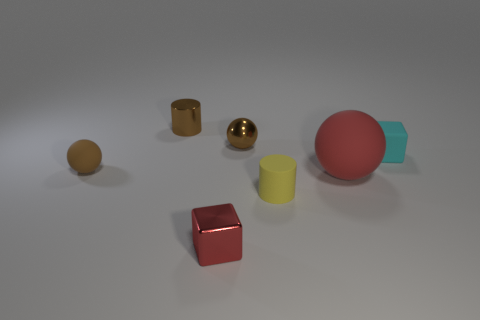There is a ball behind the cyan thing; does it have the same size as the red ball?
Your answer should be compact. No. What number of other objects are there of the same shape as the tiny cyan thing?
Give a very brief answer. 1. There is a tiny metallic thing in front of the tiny rubber block; does it have the same color as the large rubber sphere?
Offer a terse response. Yes. Are there any tiny cylinders that have the same color as the big rubber sphere?
Your response must be concise. No. How many tiny matte objects are left of the tiny cyan object?
Your response must be concise. 2. How many other objects are the same size as the cyan rubber cube?
Your answer should be compact. 5. Are the red object that is in front of the big matte object and the brown sphere that is in front of the tiny cyan rubber block made of the same material?
Give a very brief answer. No. What is the color of the rubber block that is the same size as the rubber cylinder?
Provide a short and direct response. Cyan. Are there any other things of the same color as the large rubber sphere?
Your answer should be compact. Yes. There is a cyan rubber object that is behind the tiny matte thing in front of the red thing that is on the right side of the tiny matte cylinder; how big is it?
Provide a succinct answer. Small. 